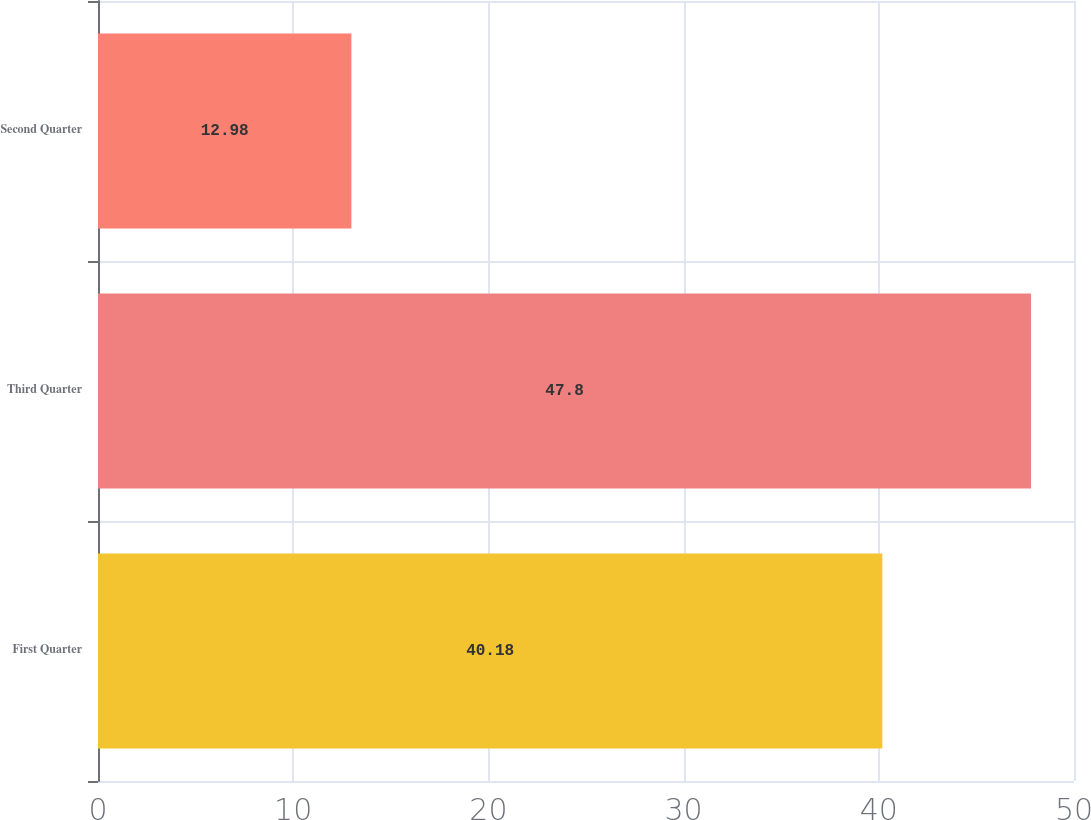Convert chart. <chart><loc_0><loc_0><loc_500><loc_500><bar_chart><fcel>First Quarter<fcel>Third Quarter<fcel>Second Quarter<nl><fcel>40.18<fcel>47.8<fcel>12.98<nl></chart> 